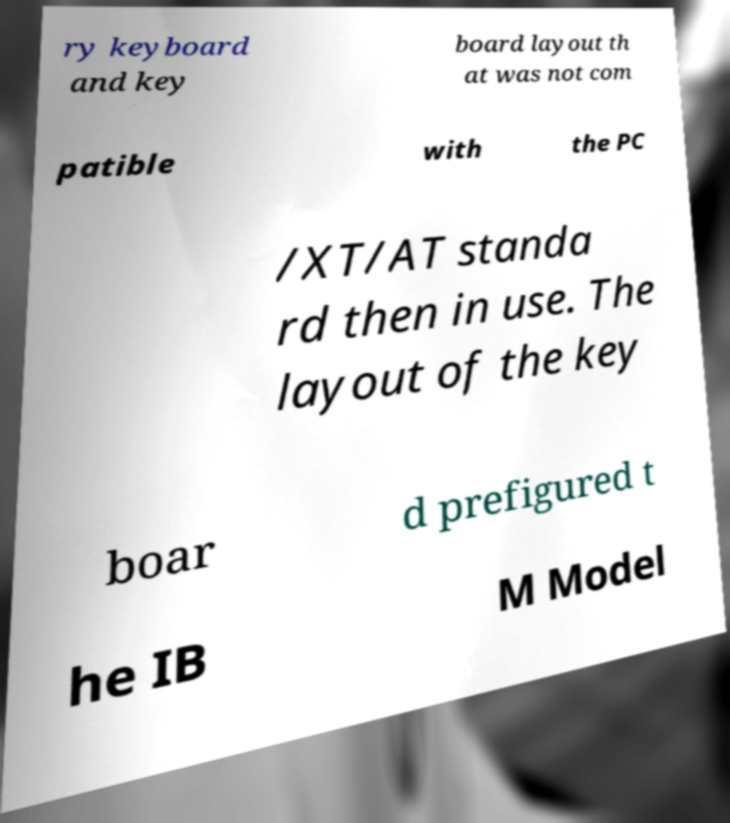I need the written content from this picture converted into text. Can you do that? ry keyboard and key board layout th at was not com patible with the PC /XT/AT standa rd then in use. The layout of the key boar d prefigured t he IB M Model 